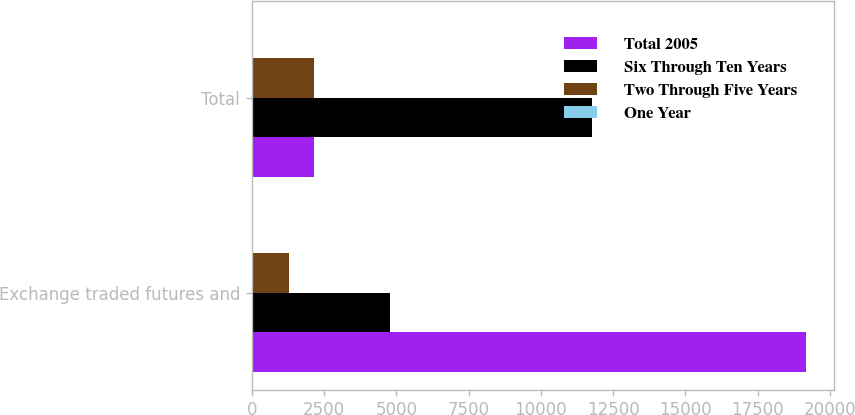Convert chart. <chart><loc_0><loc_0><loc_500><loc_500><stacked_bar_chart><ecel><fcel>Exchange traded futures and<fcel>Total<nl><fcel>Total 2005<fcel>19182<fcel>2154<nl><fcel>Six Through Ten Years<fcel>4768<fcel>11785<nl><fcel>Two Through Five Years<fcel>1287<fcel>2154<nl><fcel>One Year<fcel>61<fcel>61<nl></chart> 